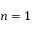Convert formula to latex. <formula><loc_0><loc_0><loc_500><loc_500>n = 1</formula> 